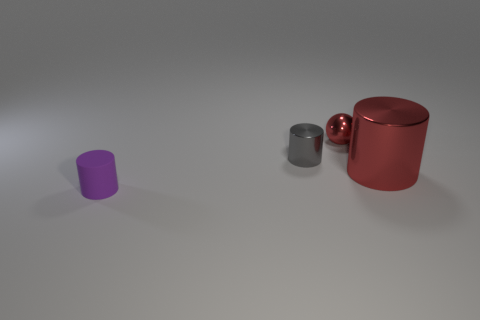Do the big metal thing and the tiny shiny ball have the same color?
Your answer should be compact. Yes. Is there anything else that has the same size as the red cylinder?
Ensure brevity in your answer.  No. Are there any other things that are the same shape as the large object?
Your answer should be compact. Yes. Do the big red shiny thing and the small purple object have the same shape?
Provide a short and direct response. Yes. Is there any other thing that is made of the same material as the purple cylinder?
Your answer should be compact. No. What size is the matte cylinder?
Offer a very short reply. Small. What color is the metallic thing that is to the left of the big object and in front of the red ball?
Offer a very short reply. Gray. What number of things are blue matte objects or cylinders on the right side of the tiny purple thing?
Your answer should be compact. 2. Does the sphere have the same size as the gray object?
Ensure brevity in your answer.  Yes. There is a small purple rubber cylinder; are there any metallic things on the right side of it?
Your answer should be very brief. Yes. 